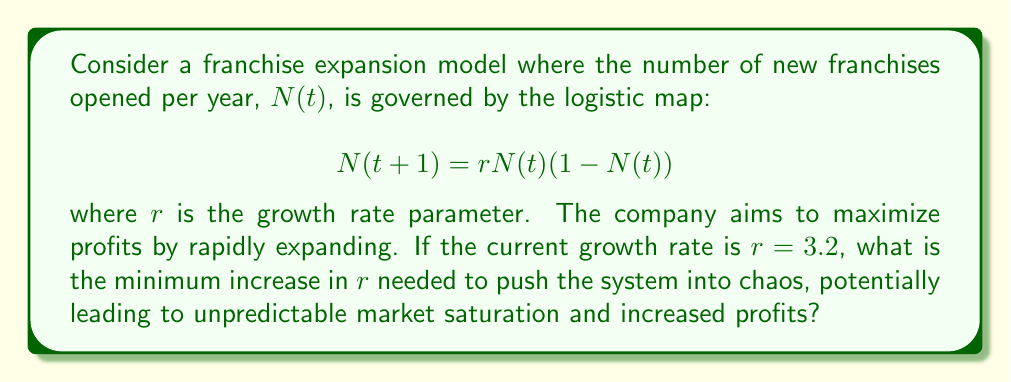Give your solution to this math problem. To solve this problem, we need to understand the behavior of the logistic map and the onset of chaos:

1. The logistic map exhibits different behaviors depending on the value of $r$:
   - For $0 < r < 1$, the population dies out.
   - For $1 < r < 3$, the population approaches a stable value.
   - For $3 < r < 3.57$, the population oscillates between two or more values.
   - For $r > 3.57$, the system enters chaos.

2. The current growth rate is $r = 3.2$, which is in the oscillating regime.

3. The onset of chaos occurs at $r \approx 3.57$ (more precisely, at $r = 3.56994...$).

4. To find the minimum increase needed:
   $$\text{Increase} = 3.57 - 3.2 = 0.37$$

5. Rounding up to ensure we reach chaos:
   $$\text{Minimum increase} = 0.37$$

This increase will push the system into chaos, potentially leading to unpredictable market behavior that could be exploited for increased profits, disregarding potential negative environmental impacts of rapid expansion.
Answer: 0.37 